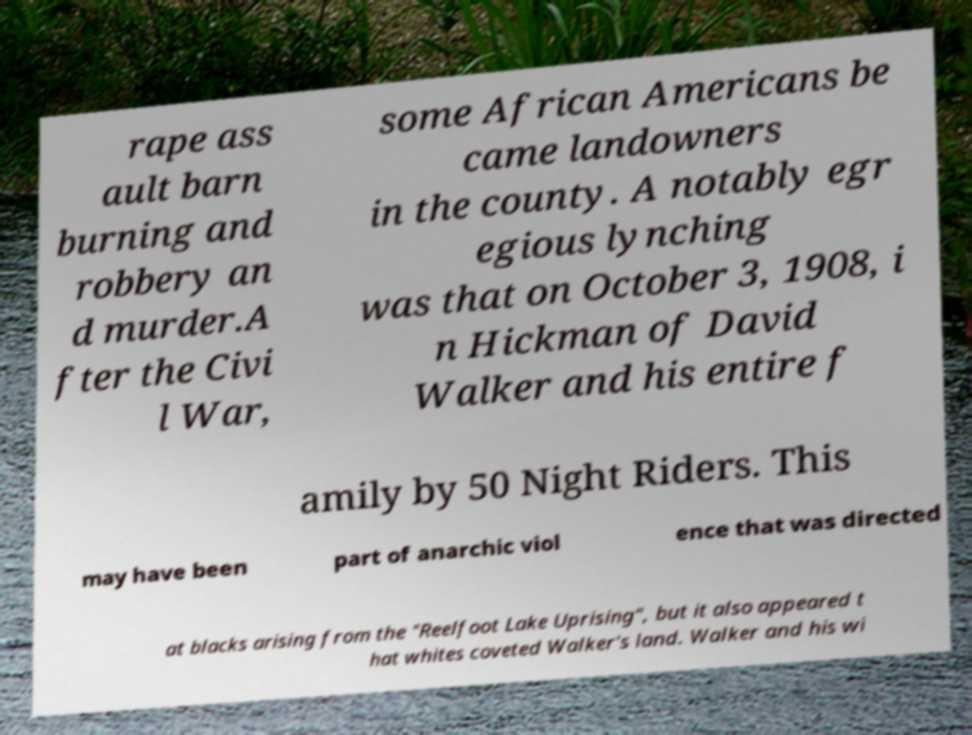Please read and relay the text visible in this image. What does it say? rape ass ault barn burning and robbery an d murder.A fter the Civi l War, some African Americans be came landowners in the county. A notably egr egious lynching was that on October 3, 1908, i n Hickman of David Walker and his entire f amily by 50 Night Riders. This may have been part of anarchic viol ence that was directed at blacks arising from the "Reelfoot Lake Uprising", but it also appeared t hat whites coveted Walker's land. Walker and his wi 